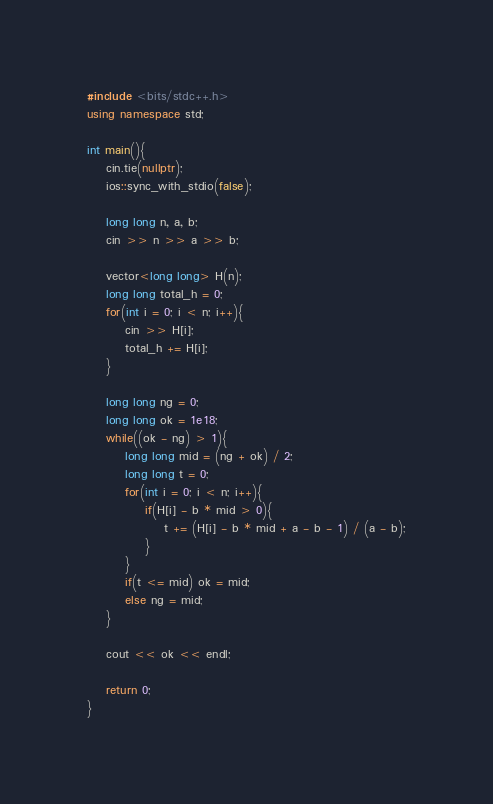Convert code to text. <code><loc_0><loc_0><loc_500><loc_500><_C++_>#include <bits/stdc++.h>
using namespace std;

int main(){
    cin.tie(nullptr);
    ios::sync_with_stdio(false);

    long long n, a, b;
    cin >> n >> a >> b;

    vector<long long> H(n);
    long long total_h = 0;
    for(int i = 0; i < n; i++){
        cin >> H[i];
        total_h += H[i];
    }

    long long ng = 0;
    long long ok = 1e18;
    while((ok - ng) > 1){
        long long mid = (ng + ok) / 2;
        long long t = 0;
        for(int i = 0; i < n; i++){
            if(H[i] - b * mid > 0){
                t += (H[i] - b * mid + a - b - 1) / (a - b);
            }
        }
        if(t <= mid) ok = mid;
        else ng = mid;
    }

    cout << ok << endl;

    return 0;
}</code> 